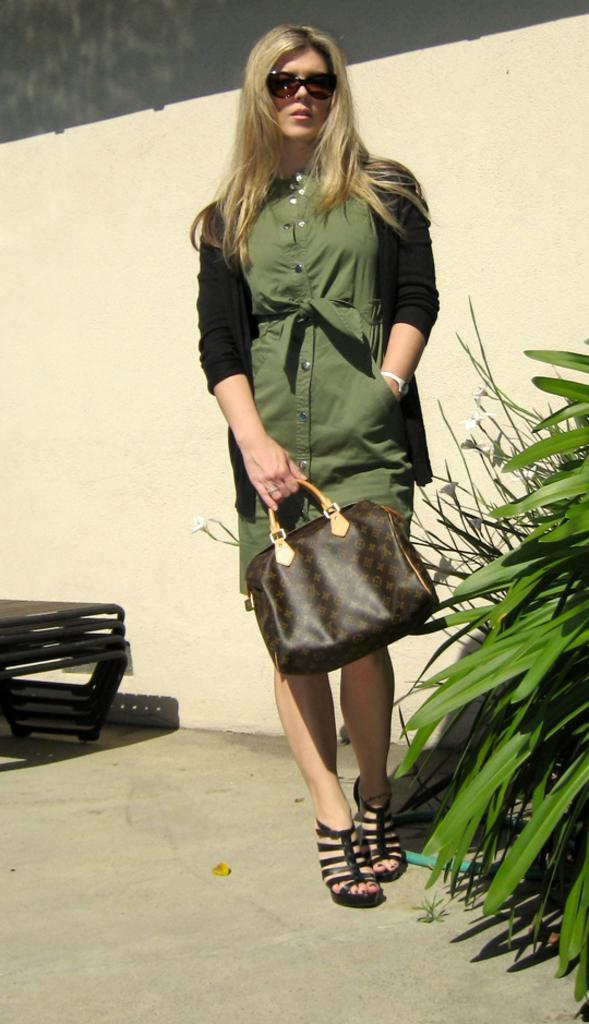Please provide a concise description of this image. a person is standing , holding a bag in her hand. at the right there are plants. behind her there is a wall. 